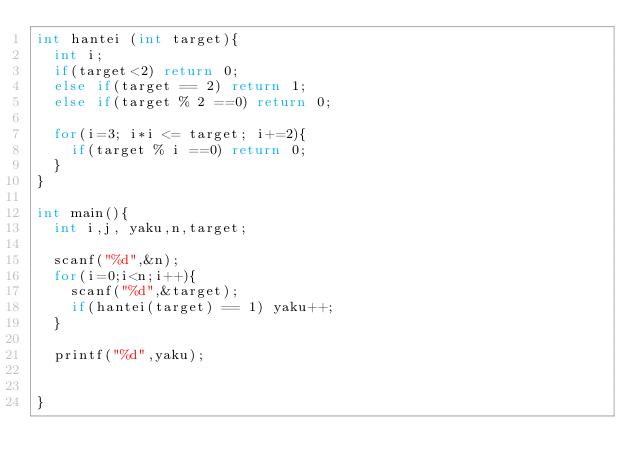Convert code to text. <code><loc_0><loc_0><loc_500><loc_500><_C_>int hantei (int target){
  int i;
  if(target<2) return 0;
  else if(target == 2) return 1;
  else if(target % 2 ==0) return 0;

  for(i=3; i*i <= target; i+=2){
    if(target % i ==0) return 0;
  }
}

int main(){
  int i,j, yaku,n,target;

  scanf("%d",&n);
  for(i=0;i<n;i++){
    scanf("%d",&target);
    if(hantei(target) == 1) yaku++;
  }

  printf("%d",yaku);

  
}

</code> 